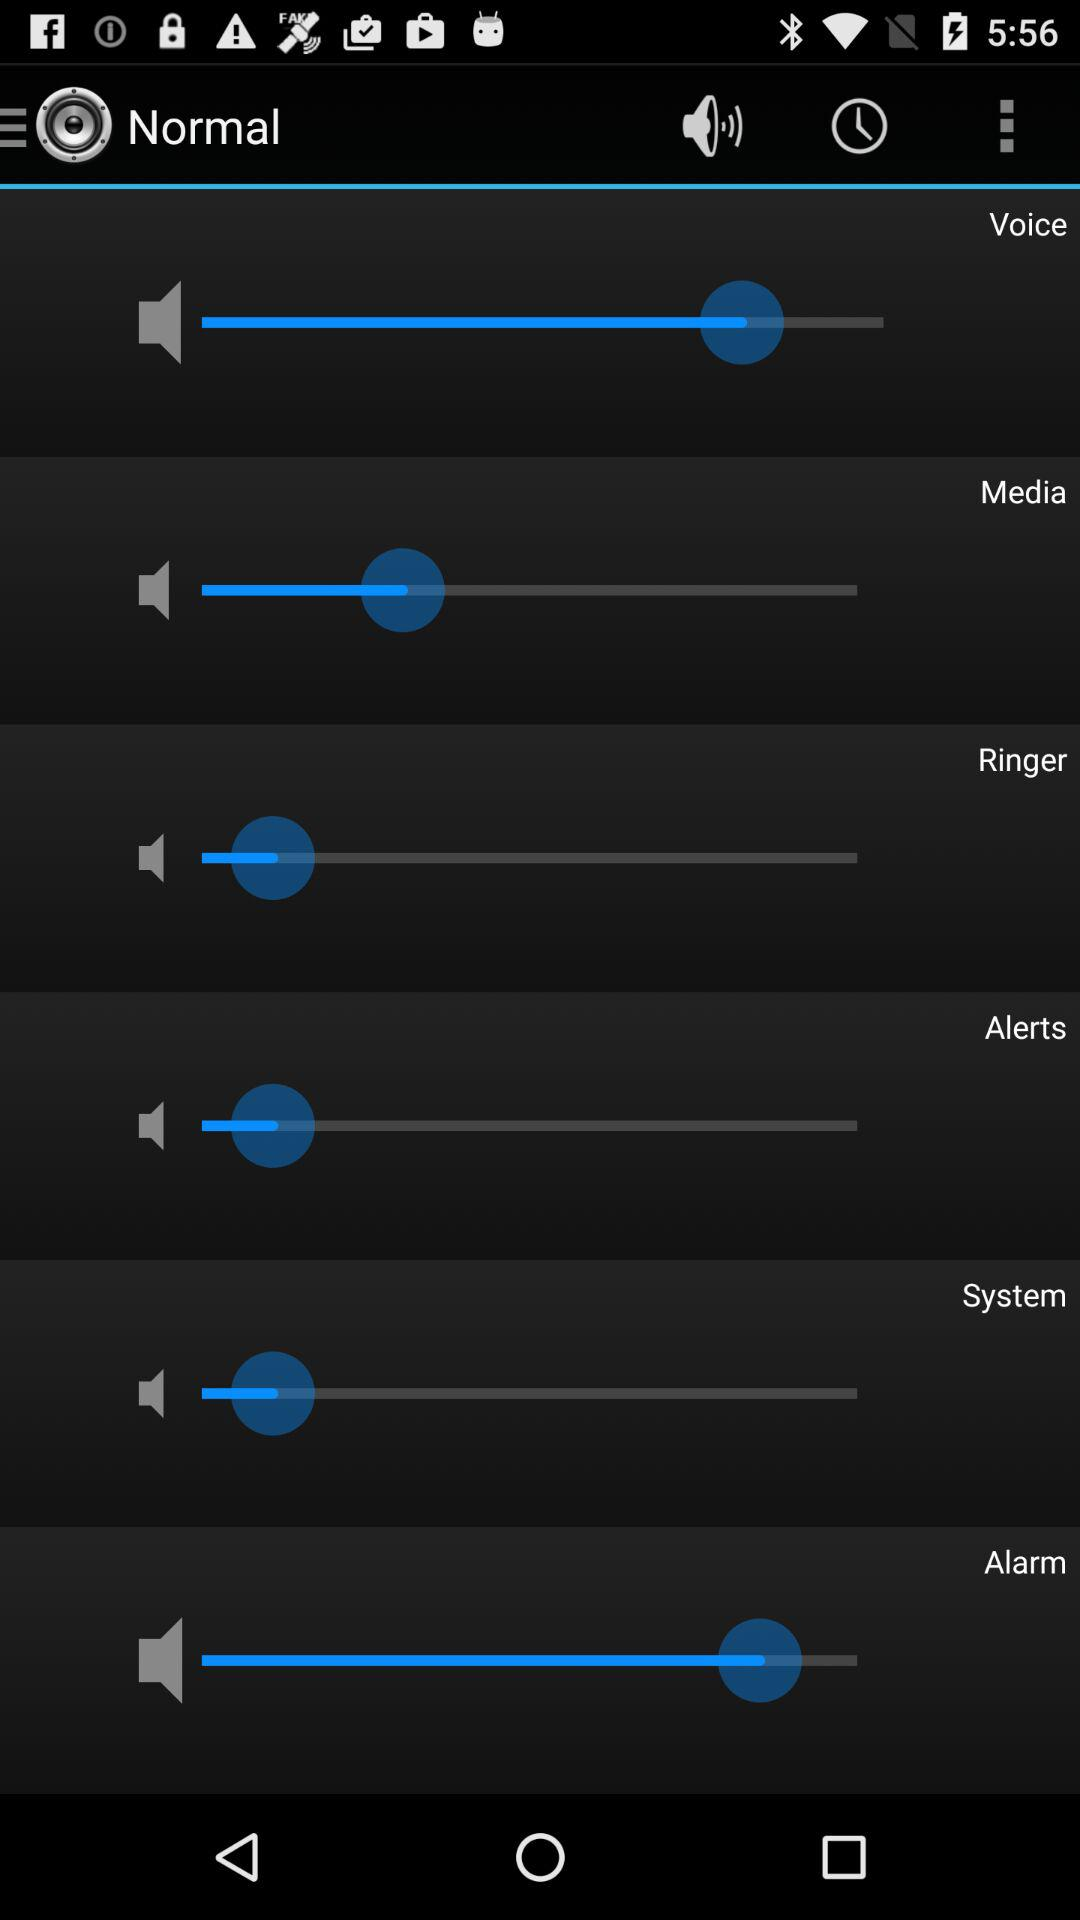What is the mode of the sound setting? The mode of the sound setting is "Normal". 